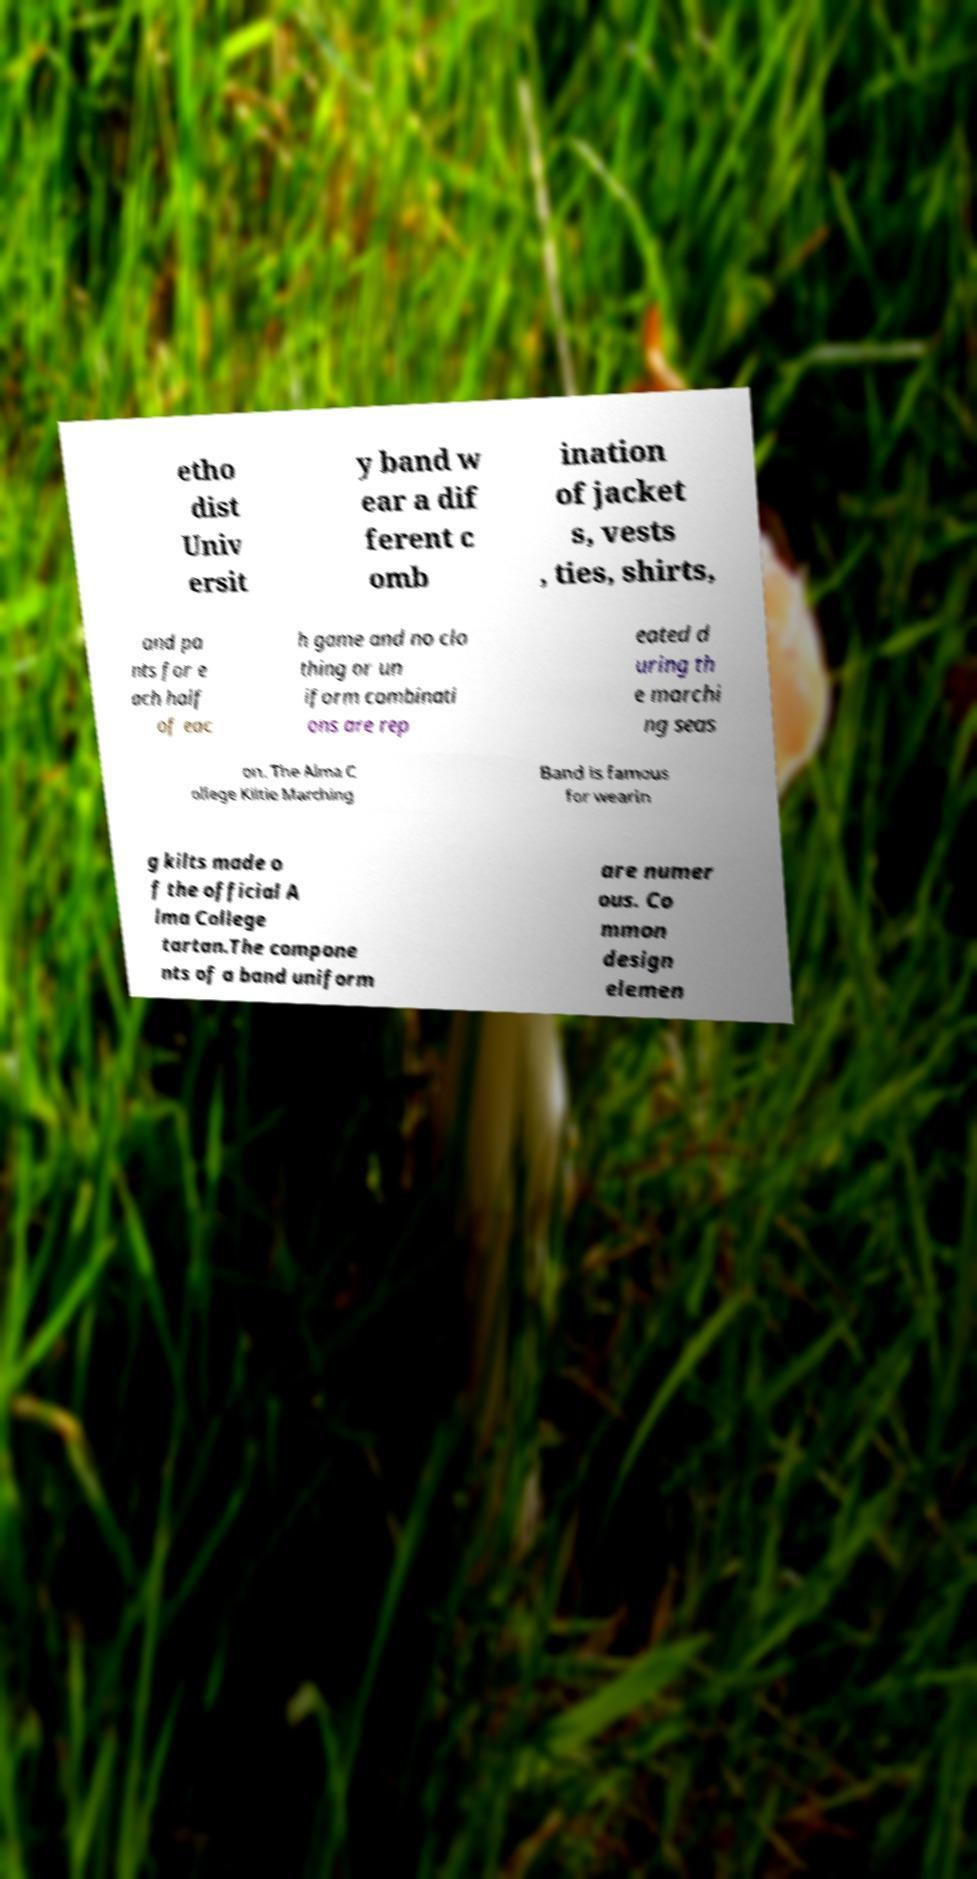For documentation purposes, I need the text within this image transcribed. Could you provide that? etho dist Univ ersit y band w ear a dif ferent c omb ination of jacket s, vests , ties, shirts, and pa nts for e ach half of eac h game and no clo thing or un iform combinati ons are rep eated d uring th e marchi ng seas on. The Alma C ollege Kiltie Marching Band is famous for wearin g kilts made o f the official A lma College tartan.The compone nts of a band uniform are numer ous. Co mmon design elemen 